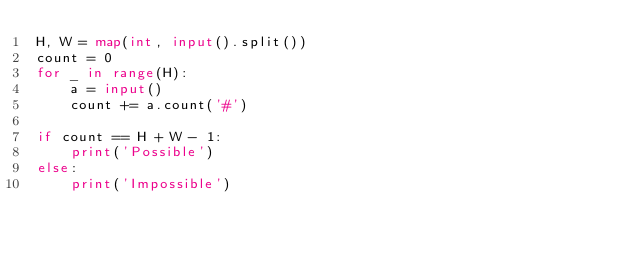<code> <loc_0><loc_0><loc_500><loc_500><_Python_>H, W = map(int, input().split())
count = 0
for _ in range(H):
    a = input()
    count += a.count('#')
 
if count == H + W - 1:
    print('Possible')
else:
    print('Impossible')</code> 